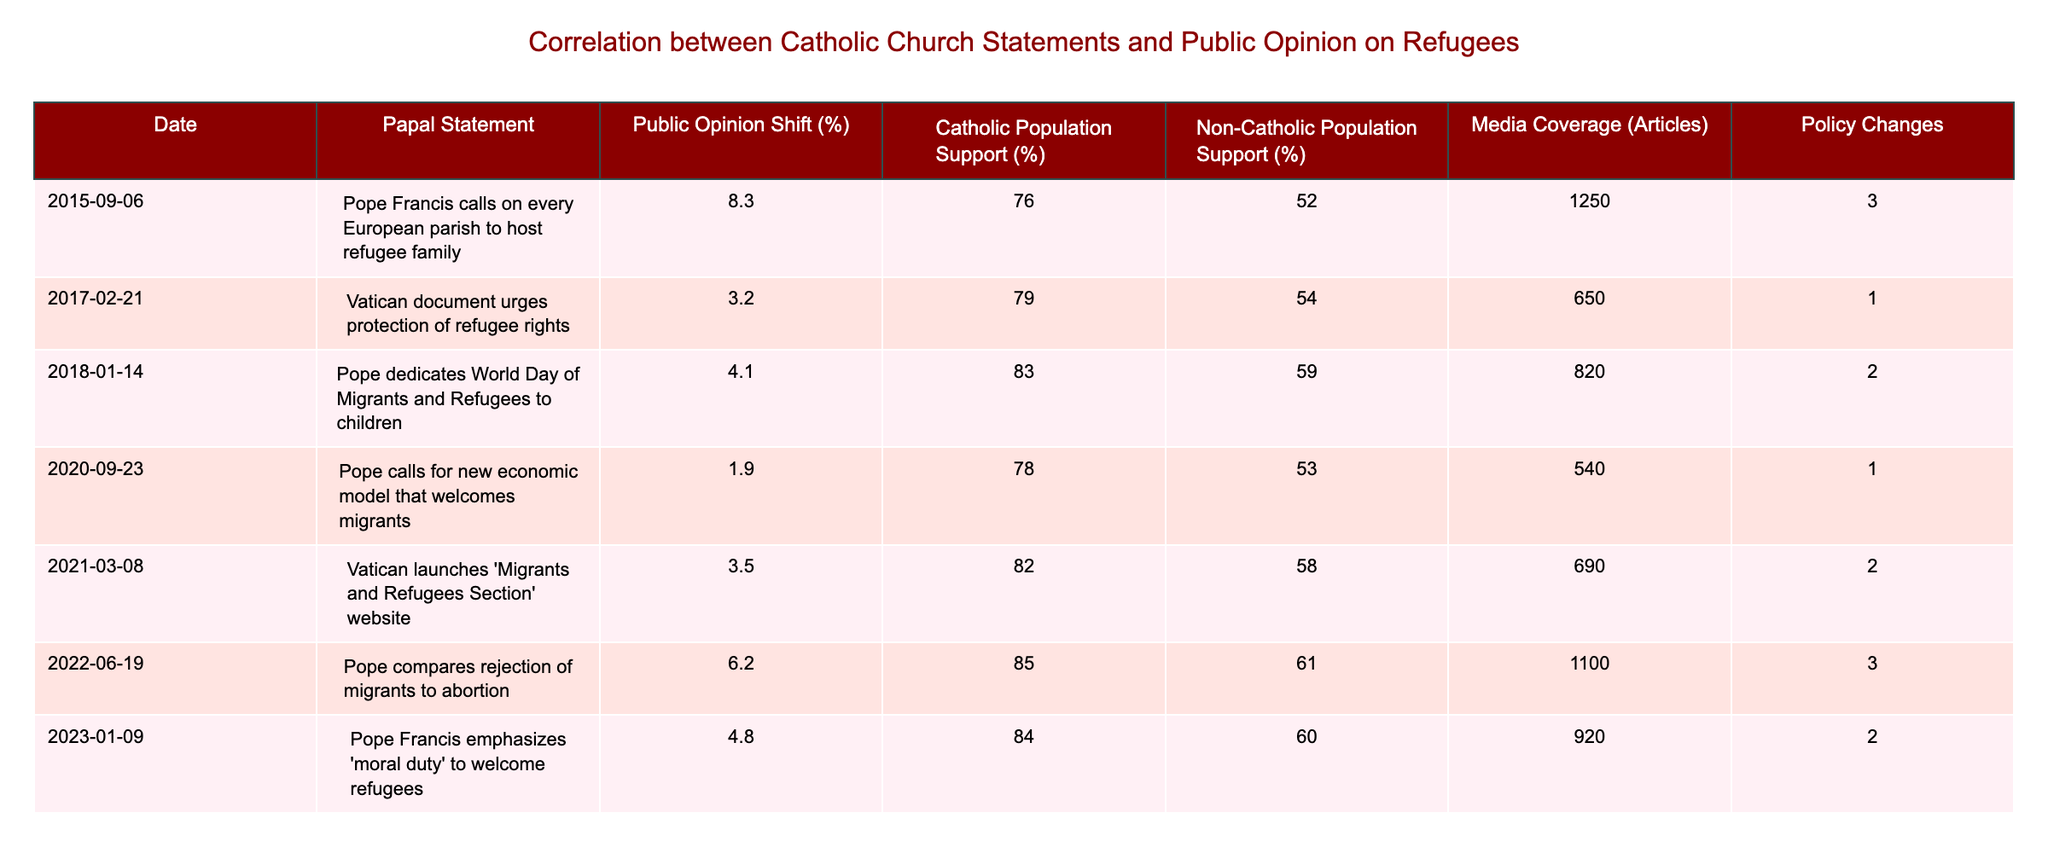What was the public opinion shift associated with the statement from 2022? The public opinion shift for the 2022 statement made by the Pope is listed as +6.2%.
Answer: 6.2% Which year saw the highest support for refugees among the Catholic population? The year with the highest support among the Catholic population was 2022, where it reached 85%.
Answer: 85% What is the difference in public opinion shift between the statements in 2015 and 2020? The public opinion shift in 2015 was +8.3%, and in 2020, it was +1.9%. The difference is 8.3 - 1.9 = 6.4%.
Answer: 6.4% Did media coverage correlate positively with public opinion shifts for all statements? Media coverage was higher for most statements, but the correlation is not necessarily positive for all. For example, the 2020 statement had lower media coverage with the smallest public opinion shift.
Answer: No What was the average public opinion shift across all statements? Adding up the public opinion shifts: 8.3 + 3.2 + 4.1 + 1.9 + 3.5 + 6.2 + 4.8 = 31.0%. Dividing by the number of statements (7) gives an average of 31.0 / 7 = approximately 4.43%.
Answer: 4.43% Which Papal statement correlates with the least Catholic population support? The 2020 statement, where the Catholic population support was 78%, correlates with the least support among the listed statements.
Answer: 78% What was the total number of articles published for statements with public opinion shifts greater than 5%? The statements with shifts greater than 5% are in 2015 (+8.3%) and 2022 (+6.2%), which had media coverage of 1250 and 1100 articles respectively. The total is 1250 + 1100 = 2350 articles.
Answer: 2350 Which year had the least amount of media coverage and what was the public opinion shift for that year? The year with the least media coverage was 2020, with 540 articles, and the public opinion shift for that year was +1.9%.
Answer: 1.9% (540 articles) Was there a decline in public opinion shifts over the last three statements? The public opinion shifts for the last three statements (2020: +1.9%, 2021: +3.5%, 2022: +6.2%) show an overall increase, not a decline.
Answer: No How does the support for refugees compare between Catholic and non-Catholic populations in 2018? In 2018, 83% of the Catholic population supported refugees, while 59% of the non-Catholic population supported them. This shows a 24% higher support among Catholics.
Answer: 24% higher among Catholics What is the overall trend of public opinion shifts based on the statements from 2015 to 2023? Analyzing the shifts: 8.3, 3.2, 4.1, 1.9, 3.5, 6.2, 4.8 indicates fluctuations with a temporary decrease from 2017 to 2020, but generally, the trend reflects varying responses influenced by Papal statements.
Answer: Fluctuating trend 